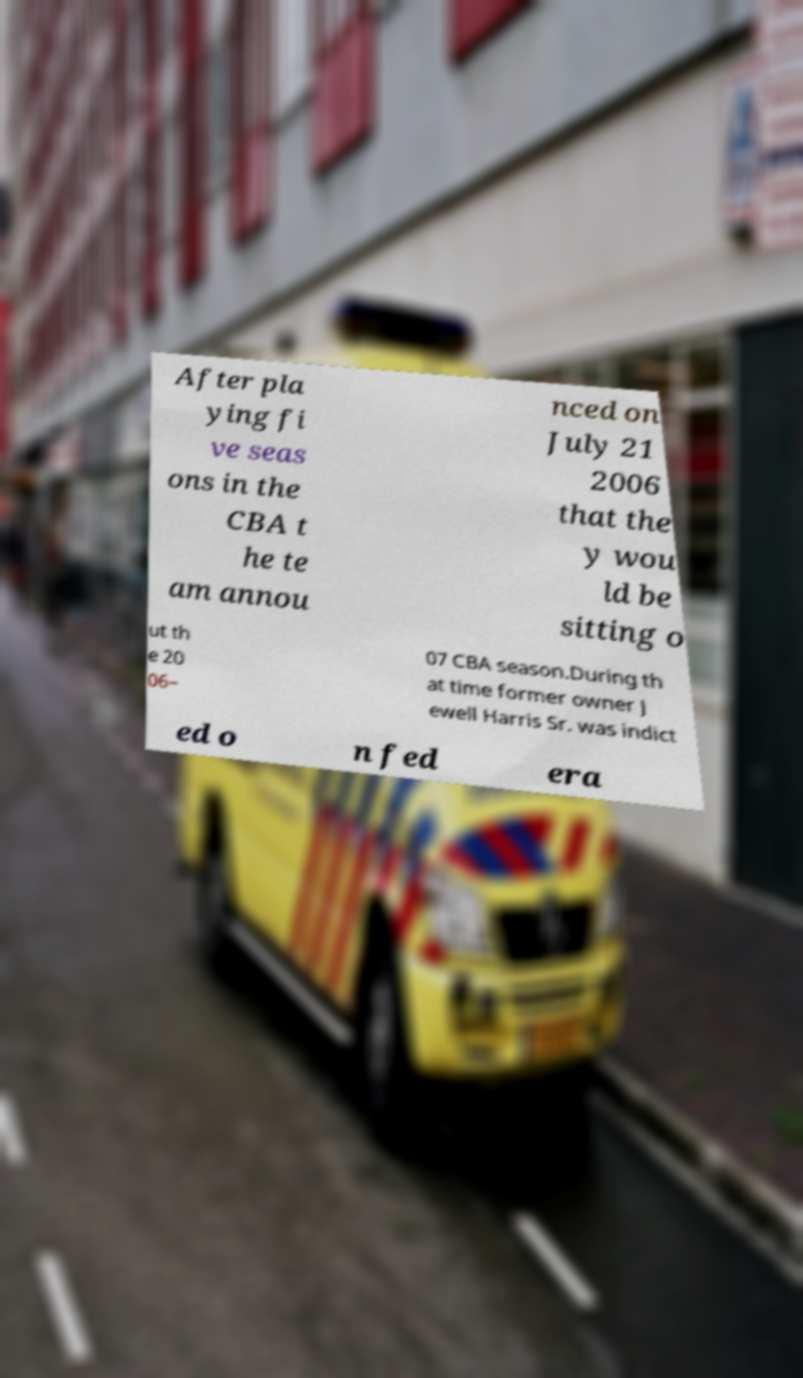Please read and relay the text visible in this image. What does it say? After pla ying fi ve seas ons in the CBA t he te am annou nced on July 21 2006 that the y wou ld be sitting o ut th e 20 06– 07 CBA season.During th at time former owner J ewell Harris Sr. was indict ed o n fed era 